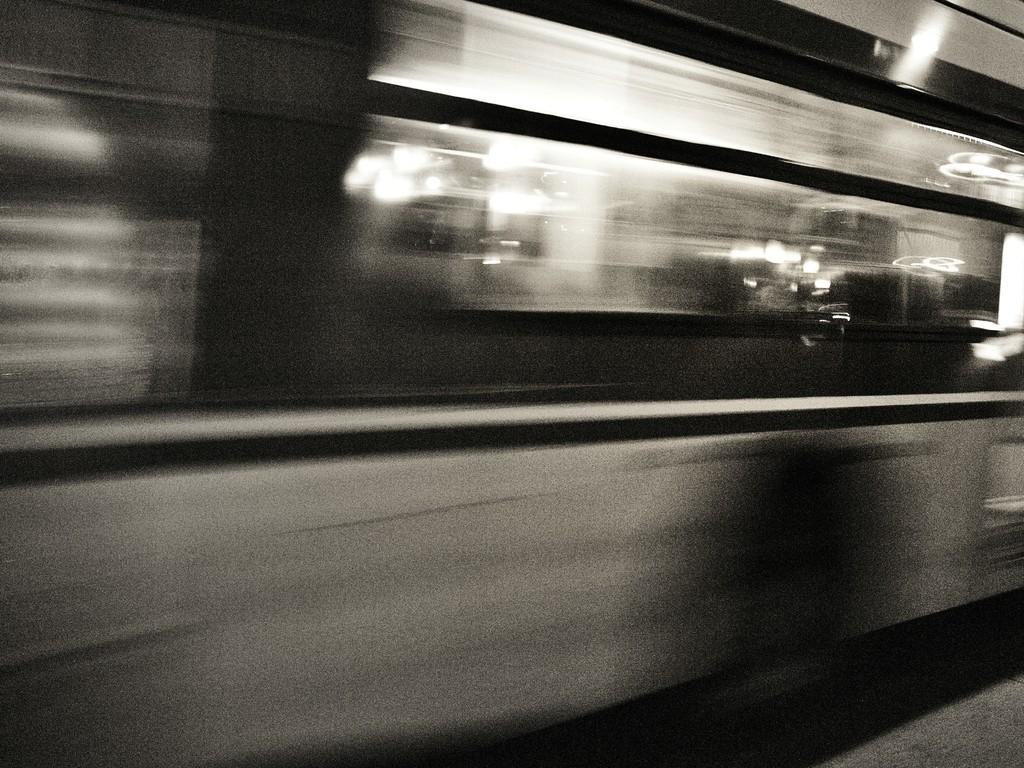What is the color scheme of the image? The image is black and white. What is the main subject of the image? There is a moving train in the image. Where is the train located in the image? The train is on a track. How many owls are sitting on the train in the image? There are no owls present in the image; it features a moving train on a track. What type of committee is responsible for the train's maintenance in the image? There is no information about a committee responsible for the train's maintenance in the image. 